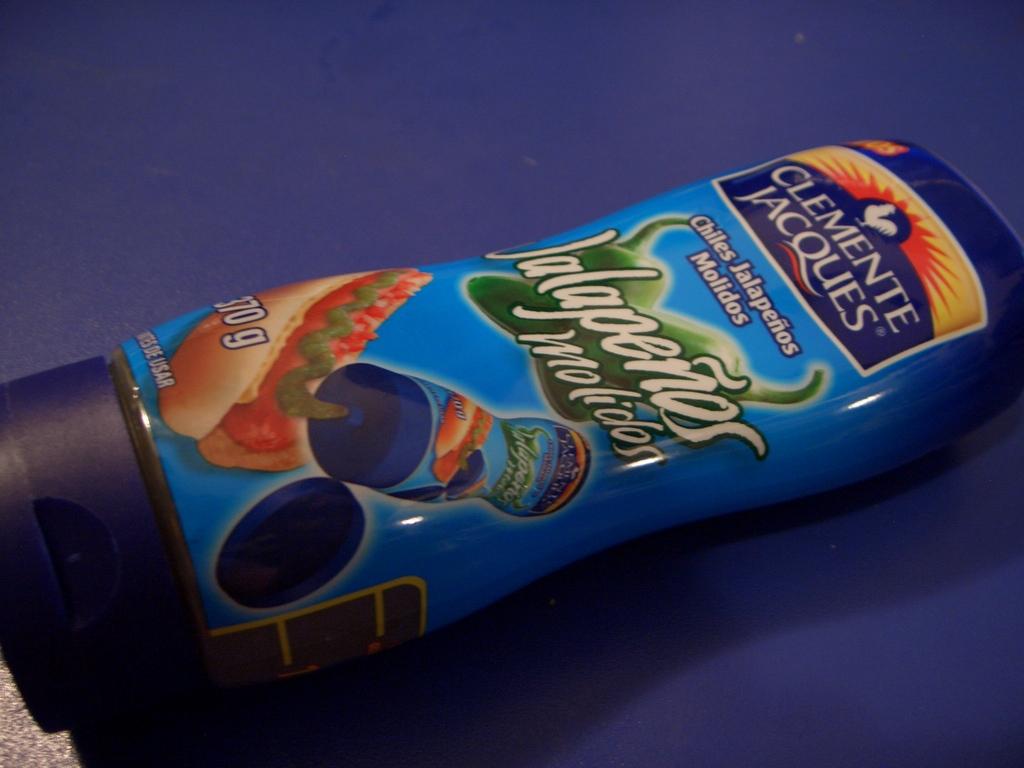How many g are in the bottle?
Keep it short and to the point. 370. What brand is this?
Offer a very short reply. Clemente jacques. 